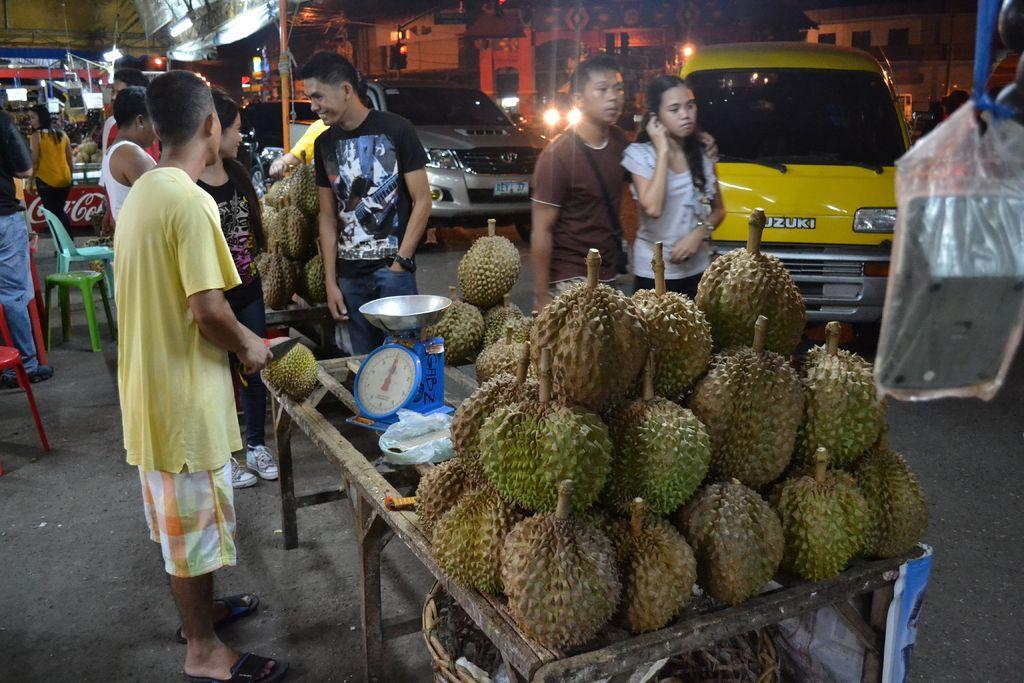Could you give a brief overview of what you see in this image? In this picture I can see some vehicles are on the road, side some fruits are placed on the tables, around I can see some few people and behind there are some buildings. 